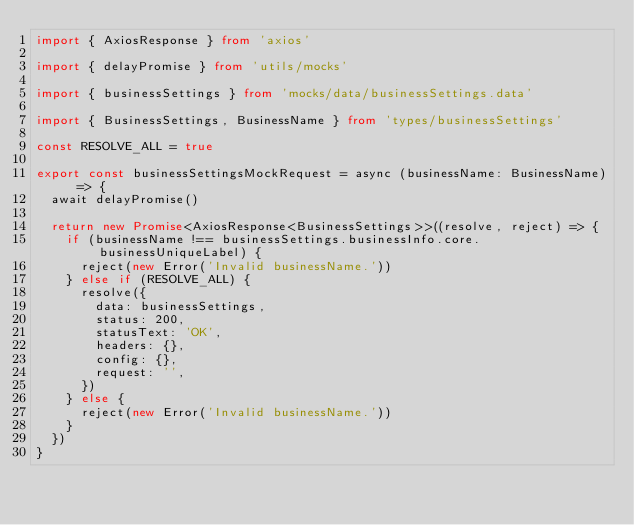Convert code to text. <code><loc_0><loc_0><loc_500><loc_500><_TypeScript_>import { AxiosResponse } from 'axios'

import { delayPromise } from 'utils/mocks'

import { businessSettings } from 'mocks/data/businessSettings.data'

import { BusinessSettings, BusinessName } from 'types/businessSettings'

const RESOLVE_ALL = true

export const businessSettingsMockRequest = async (businessName: BusinessName) => {
  await delayPromise()

  return new Promise<AxiosResponse<BusinessSettings>>((resolve, reject) => {
    if (businessName !== businessSettings.businessInfo.core.businessUniqueLabel) {
      reject(new Error('Invalid businessName.'))
    } else if (RESOLVE_ALL) {
      resolve({
        data: businessSettings,
        status: 200,
        statusText: 'OK',
        headers: {},
        config: {},
        request: '',
      })
    } else {
      reject(new Error('Invalid businessName.'))
    }
  })
}
</code> 